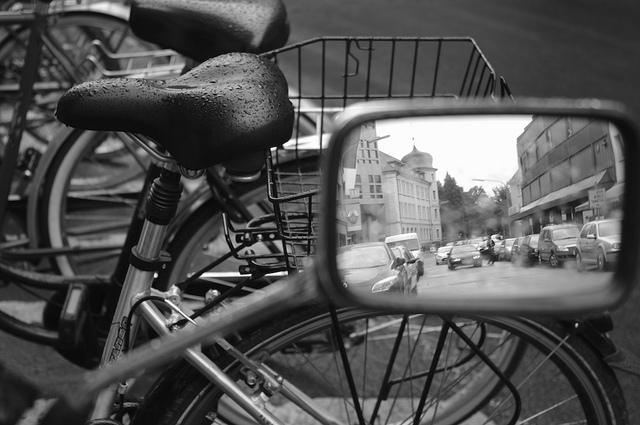Is there a bus on the street?
Be succinct. No. Is it raining?
Give a very brief answer. Yes. Is this mirror on a bicycle?
Give a very brief answer. Yes. How many cars are in the rearview mirror?
Concise answer only. 9. 